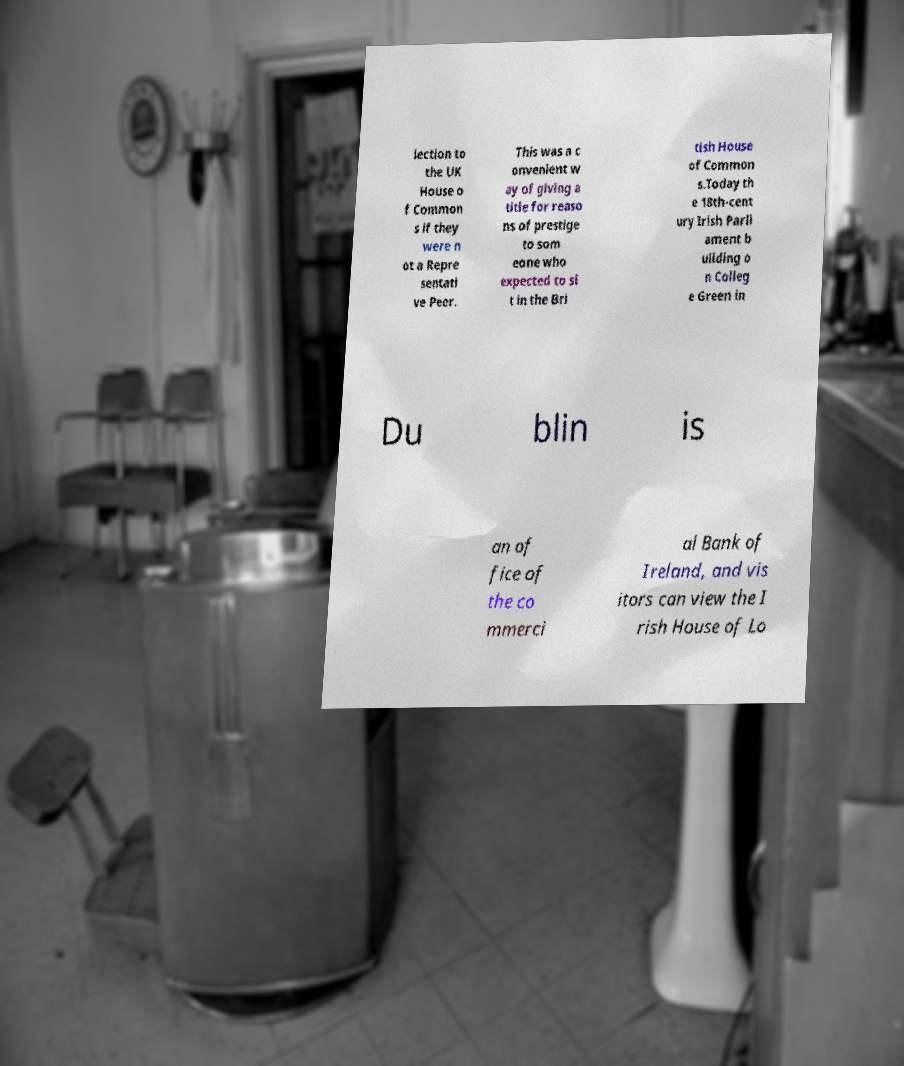Please identify and transcribe the text found in this image. lection to the UK House o f Common s if they were n ot a Repre sentati ve Peer. This was a c onvenient w ay of giving a title for reaso ns of prestige to som eone who expected to si t in the Bri tish House of Common s.Today th e 18th-cent ury Irish Parli ament b uilding o n Colleg e Green in Du blin is an of fice of the co mmerci al Bank of Ireland, and vis itors can view the I rish House of Lo 